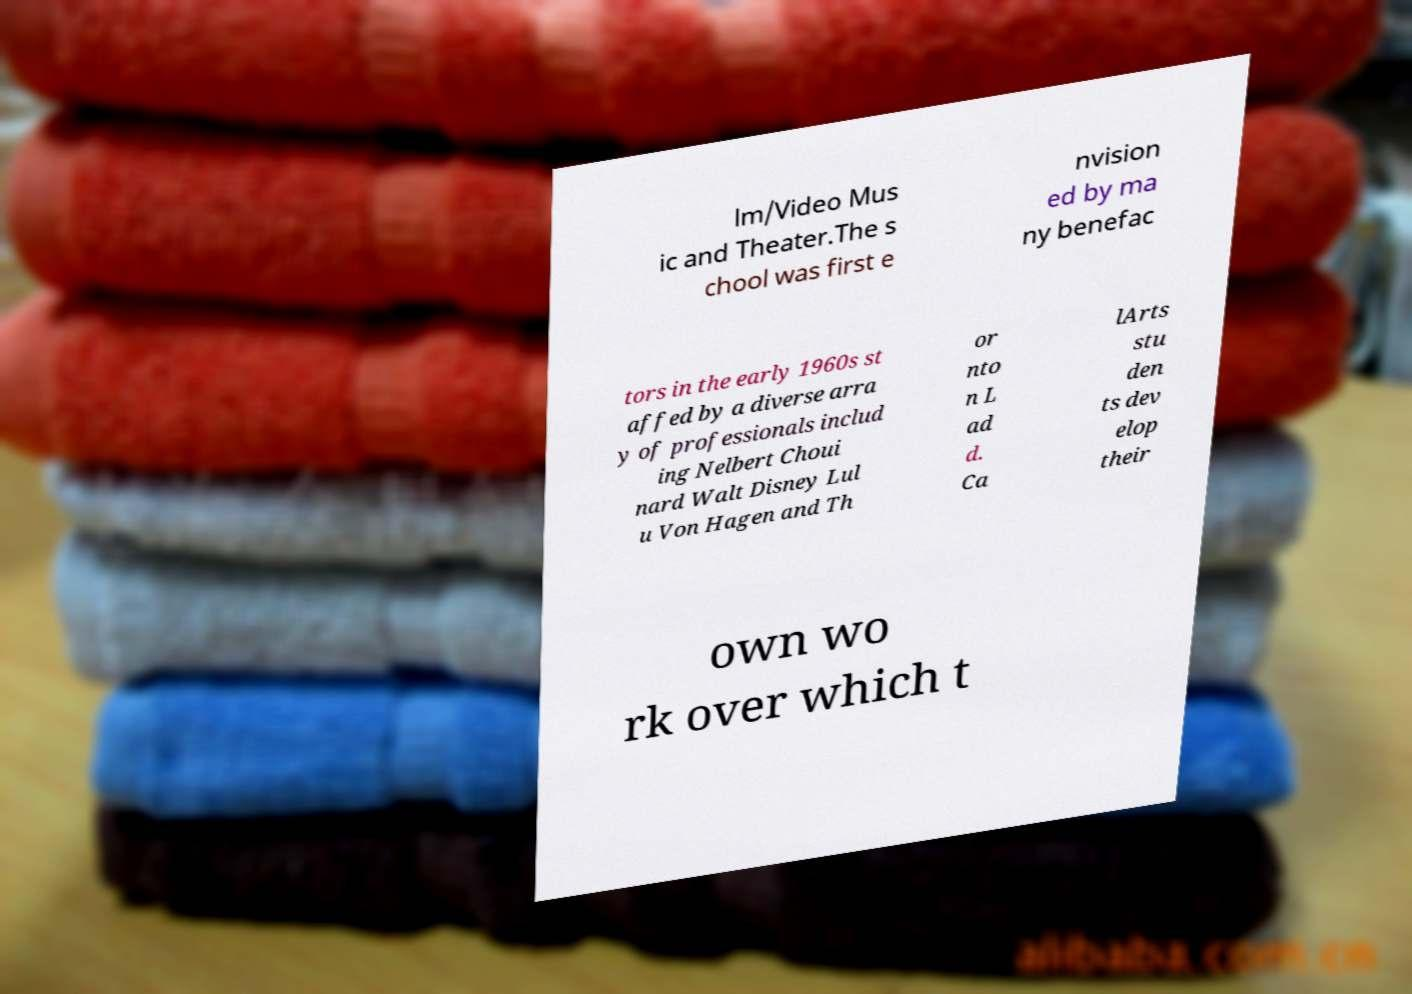Could you extract and type out the text from this image? lm/Video Mus ic and Theater.The s chool was first e nvision ed by ma ny benefac tors in the early 1960s st affed by a diverse arra y of professionals includ ing Nelbert Choui nard Walt Disney Lul u Von Hagen and Th or nto n L ad d. Ca lArts stu den ts dev elop their own wo rk over which t 